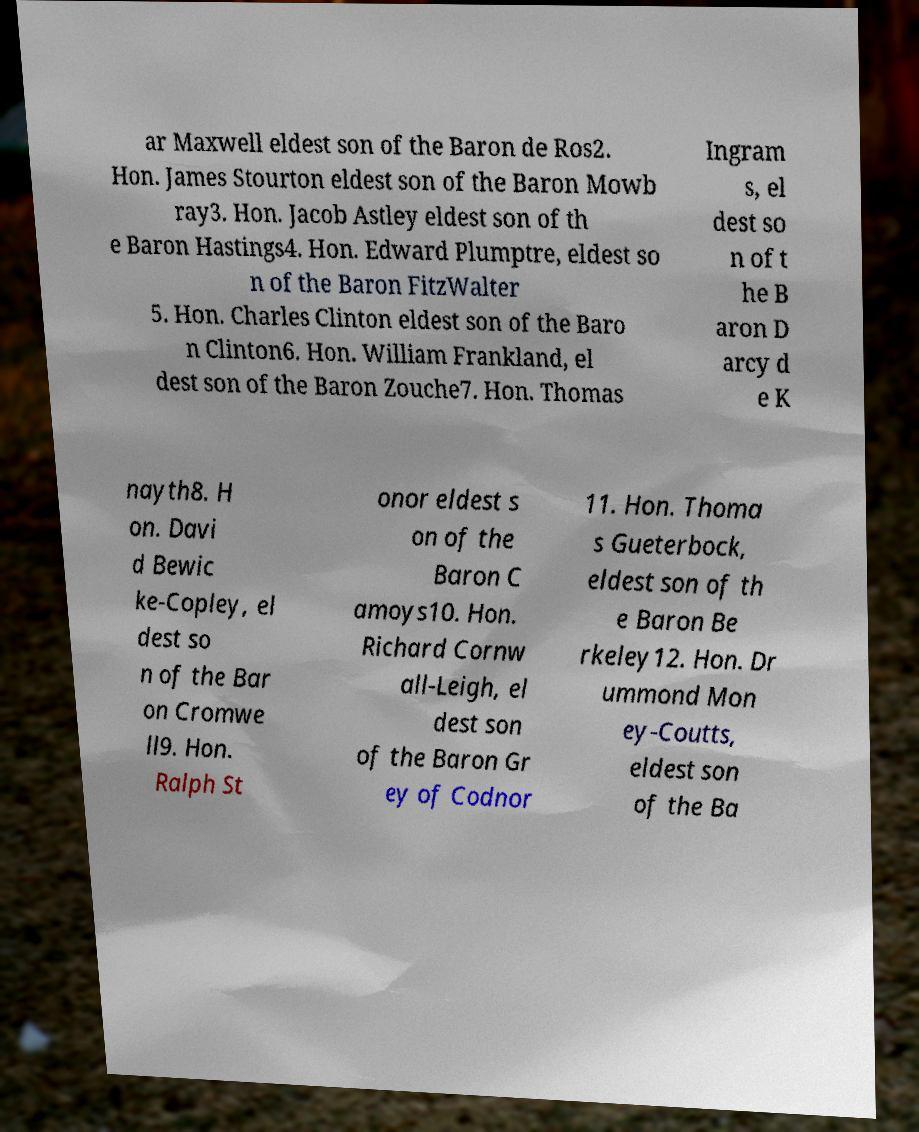For documentation purposes, I need the text within this image transcribed. Could you provide that? ar Maxwell eldest son of the Baron de Ros2. Hon. James Stourton eldest son of the Baron Mowb ray3. Hon. Jacob Astley eldest son of th e Baron Hastings4. Hon. Edward Plumptre, eldest so n of the Baron FitzWalter 5. Hon. Charles Clinton eldest son of the Baro n Clinton6. Hon. William Frankland, el dest son of the Baron Zouche7. Hon. Thomas Ingram s, el dest so n of t he B aron D arcy d e K nayth8. H on. Davi d Bewic ke-Copley, el dest so n of the Bar on Cromwe ll9. Hon. Ralph St onor eldest s on of the Baron C amoys10. Hon. Richard Cornw all-Leigh, el dest son of the Baron Gr ey of Codnor 11. Hon. Thoma s Gueterbock, eldest son of th e Baron Be rkeley12. Hon. Dr ummond Mon ey-Coutts, eldest son of the Ba 